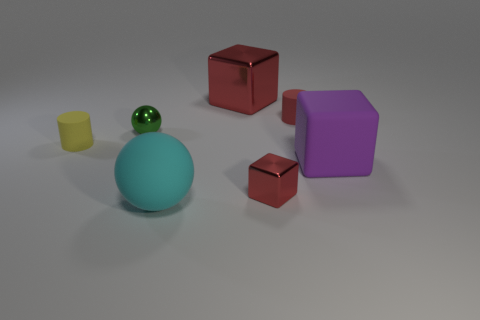What materials do these objects appear to be made of? The small yellow object seems to be made of plastic, the green object atop the blue sphere could be glass or polished stone, the blue sphere and the purple pentagonal prism appear to be matte finished, suggesting a plastic or rubber material, and the two red objects resemble shiny, metallic cubes. 